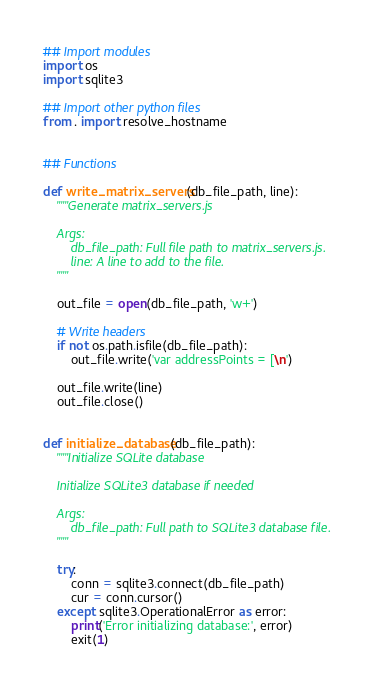Convert code to text. <code><loc_0><loc_0><loc_500><loc_500><_Python_>## Import modules
import os
import sqlite3

## Import other python files
from . import resolve_hostname


## Functions

def write_matrix_servers(db_file_path, line):
    """Generate matrix_servers.js

    Args:
        db_file_path: Full file path to matrix_servers.js.
        line: A line to add to the file.
    """

    out_file = open(db_file_path, 'w+')

    # Write headers
    if not os.path.isfile(db_file_path):
        out_file.write('var addressPoints = [\n')

    out_file.write(line)
    out_file.close()


def initialize_database(db_file_path):
    """Initialize SQLite database

    Initialize SQLite3 database if needed

    Args:
        db_file_path: Full path to SQLite3 database file.
    """

    try:
        conn = sqlite3.connect(db_file_path)
        cur = conn.cursor()
    except sqlite3.OperationalError as error:
        print('Error initializing database:', error)
        exit(1)</code> 